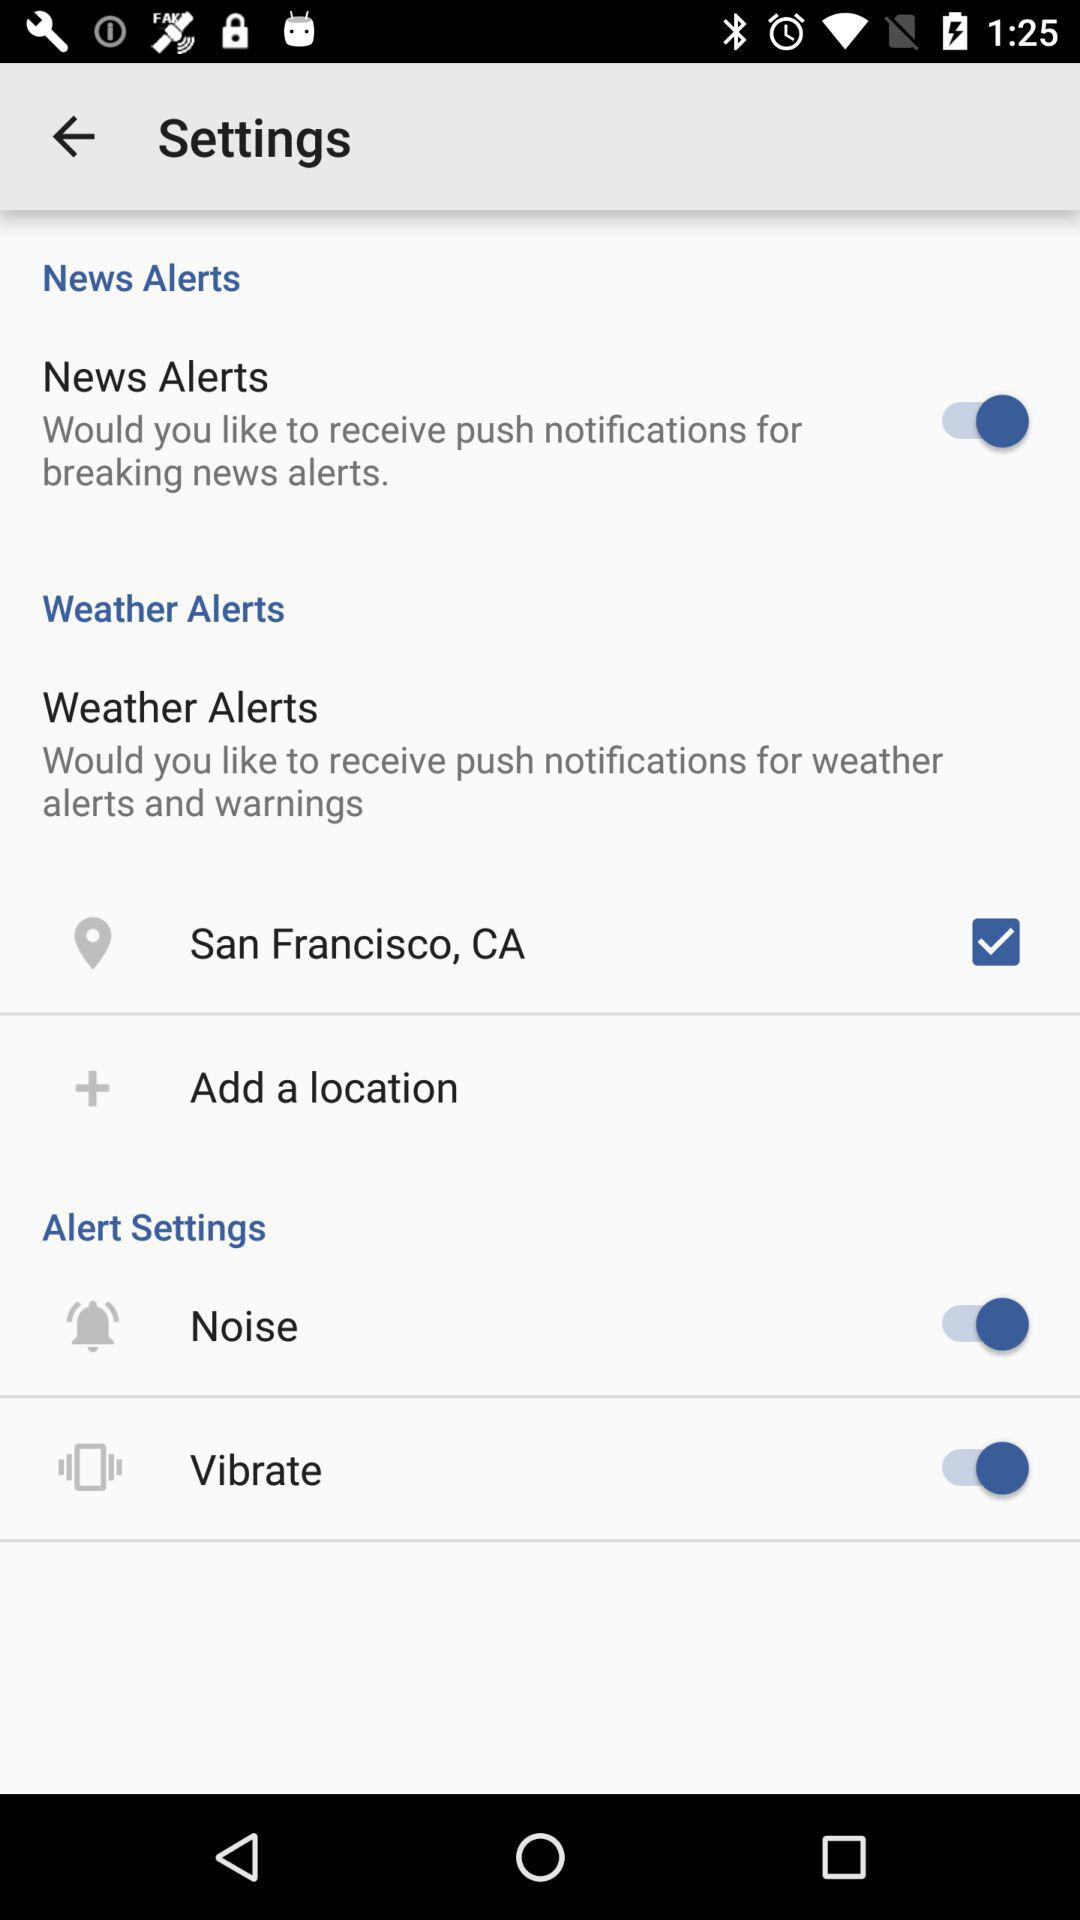What are the options given in the "Alert Settings"? The given options are "Noise" and "Vibrate". 